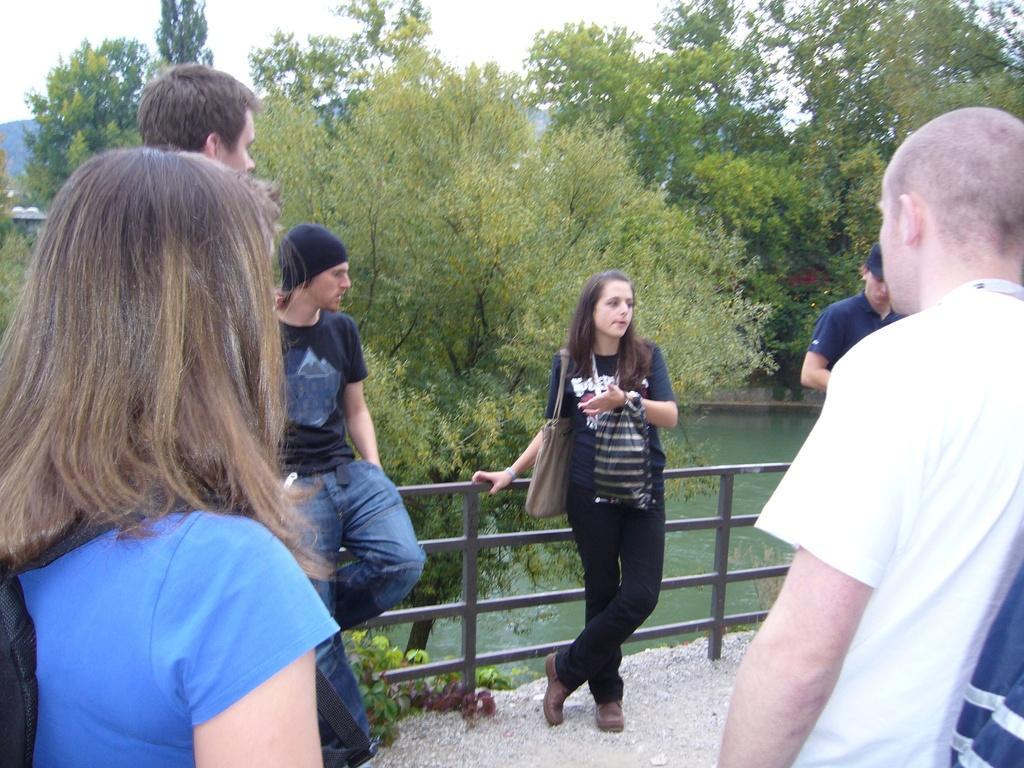Can you describe this image briefly? As we can see in the image there are lot of trees and below there is a lake and there is a bridge in between where people are standing on it and leaning to the fencing. 